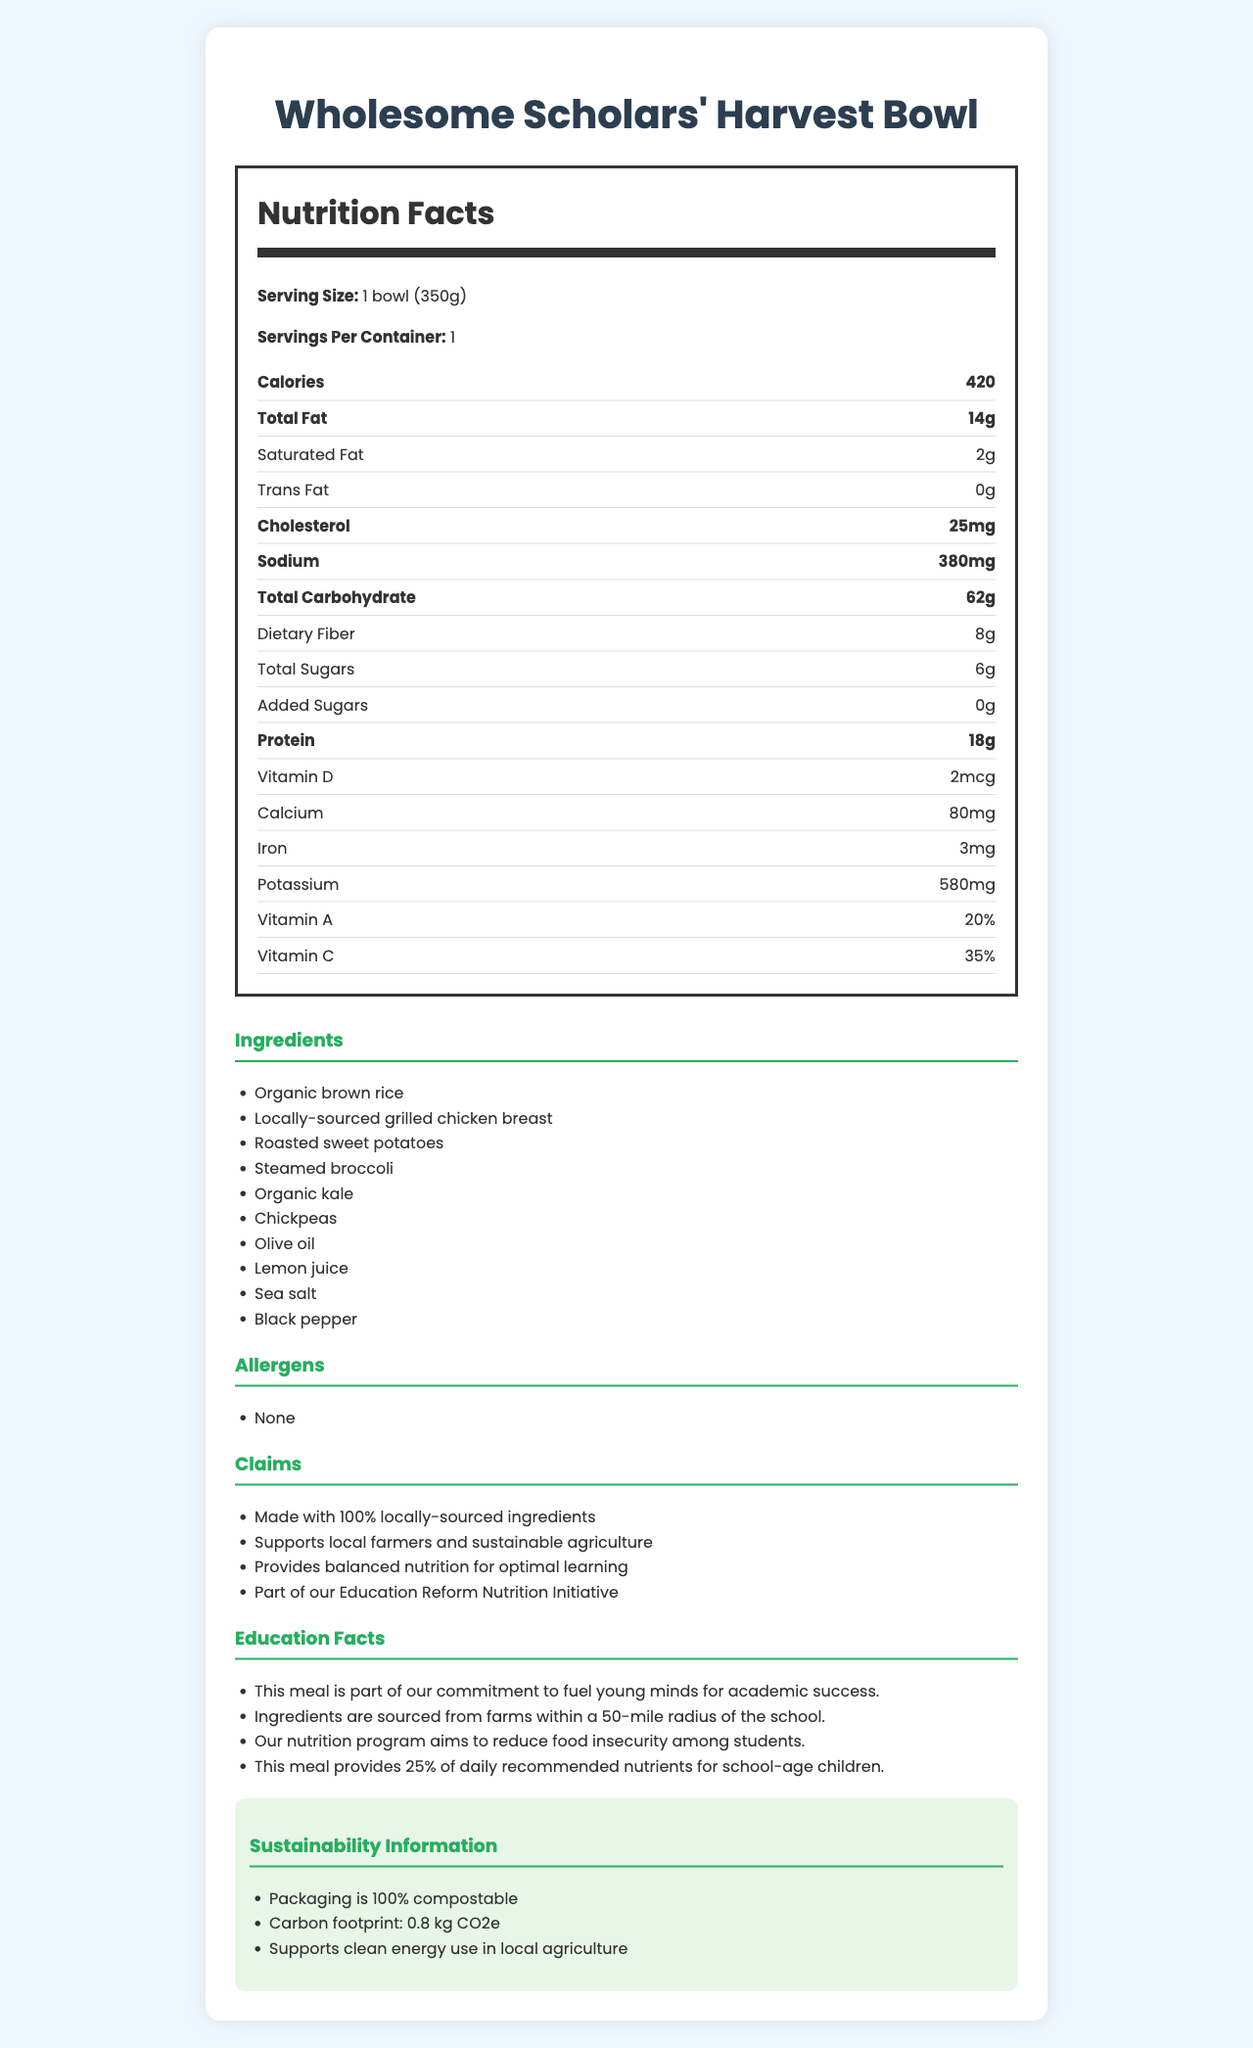what is the serving size for the Wholesome Scholars' Harvest Bowl? The serving size is clearly stated at the top of the nutrition facts section.
Answer: 1 bowl (350g) how many calories are in one bowl of the Wholesome Scholars' Harvest Bowl? The document lists the calorie content as 420.
Answer: 420 what is the total carbohydrate content in one serving? The nutrition label specifies that the total carbohydrate amount per serving is 62 grams.
Answer: 62g how much protein does one bowl provide? The amount of protein per serving is listed as 18 grams.
Answer: 18g are there any allergens in the Wholesome Scholars' Harvest Bowl? The document explicitly mentions that there are no allergens in this meal.
Answer: None what percent of daily vitamin C is provided by this meal? The document states that the meal provides 35% of the daily recommended vitamin C.
Answer: 35% which of the following is NOT an ingredient in the Wholesome Scholars' Harvest Bowl? 
A. Organic brown rice 
B. Roasted sweet potatoes 
C. Quinoa 
D. Steamed broccoli Quinoa is not listed among the ingredients.
Answer: C what is the carbon footprint of this meal? 
1. 1.2 kg CO2e 
2. 0.8 kg CO2e 
3. 0.5 kg CO2e The document lists the carbon footprint as 0.8 kg CO2e.
Answer: 2 does this meal contain any added sugars? The document states that the meal contains 0 grams of added sugars.
Answer: No describe the main idea of the document. This summary captures the overall content and purpose of the document, which details various aspects of the Wholesome Scholars' Harvest Bowl.
Answer: The document presents the nutrition facts, ingredients, allergen information, and sustainability claims for the Wholesome Scholars' Harvest Bowl, a locally-sourced school lunch meal supporting education reform. how much calcium is provided in one serving of the meal? The nutrition label indicates that there is 80mg of calcium per serving.
Answer: 80mg is the packaging of the Wholesome Scholars' Harvest Bowl compostable? The sustainability information section mentions that the packaging is 100% compostable.
Answer: Yes what ingredients are sourced from local farms? The document claims that the meal is made with 100% locally-sourced ingredients.
Answer: Organic brown rice, locally-sourced grilled chicken breast, roasted sweet potatoes, steamed broccoli, organic kale, chickpeas, olive oil, lemon juice, sea salt, black pepper what is the main objective of this meal concerning education? The education facts section mentions these objectives explicitly.
Answer: To fuel young minds for academic success and reduce food insecurity among students how many of the daily recommended nutrients for school-age children does this meal provide? The document states that the meal provides 25% of the daily recommended nutrients for school-age children.
Answer: 25% what is the cholesterol content in one serving? The nutrition label indicates that there is 25mg of cholesterol per serving.
Answer: 25mg what is the total fat content in the meal? The nutrition label specifies that there are 14 grams of total fat in one serving.
Answer: 14g where are the ingredients for this meal sourced from? One of the education facts states that the ingredients come from farms within a 50-mile radius.
Answer: Farms within a 50-mile radius of the school does this meal contain any vitamin D? The document mentions that the meal contains 2mcg of vitamin D.
Answer: Yes who are the local farmers that supply ingredients for the Wholesome Scholars' Harvest Bowl? The document does not specify the individual local farmers who supply the ingredients.
Answer: Not enough information 